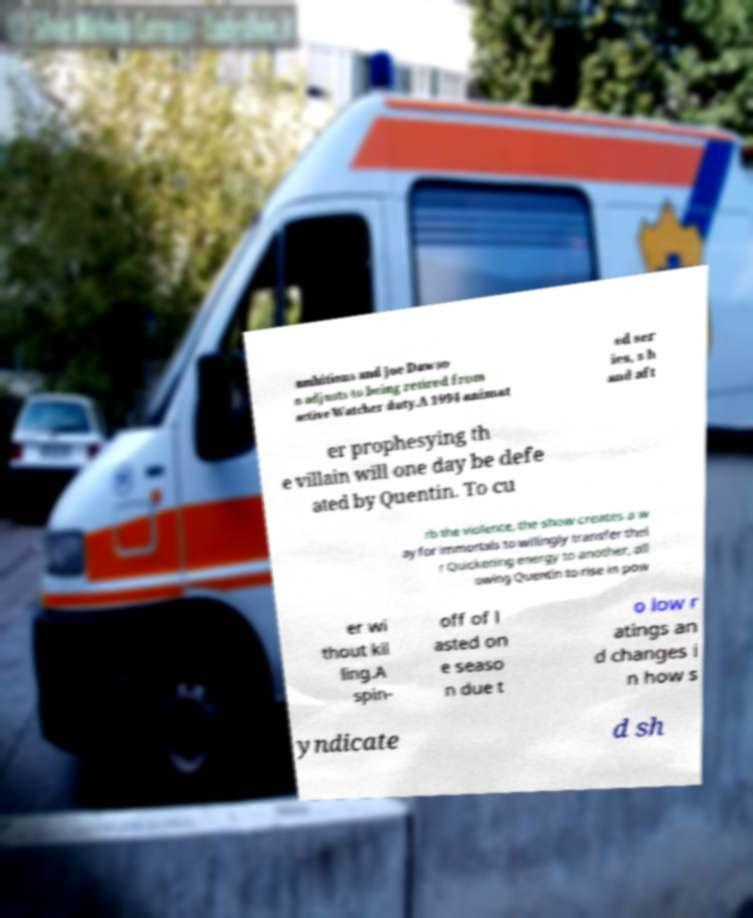Please identify and transcribe the text found in this image. ambitions and Joe Dawso n adjusts to being retired from active Watcher duty.A 1994 animat ed ser ies, s h and aft er prophesying th e villain will one day be defe ated by Quentin. To cu rb the violence, the show creates a w ay for immortals to willingly transfer thei r Quickening energy to another, all owing Quentin to rise in pow er wi thout kil ling.A spin- off of l asted on e seaso n due t o low r atings an d changes i n how s yndicate d sh 